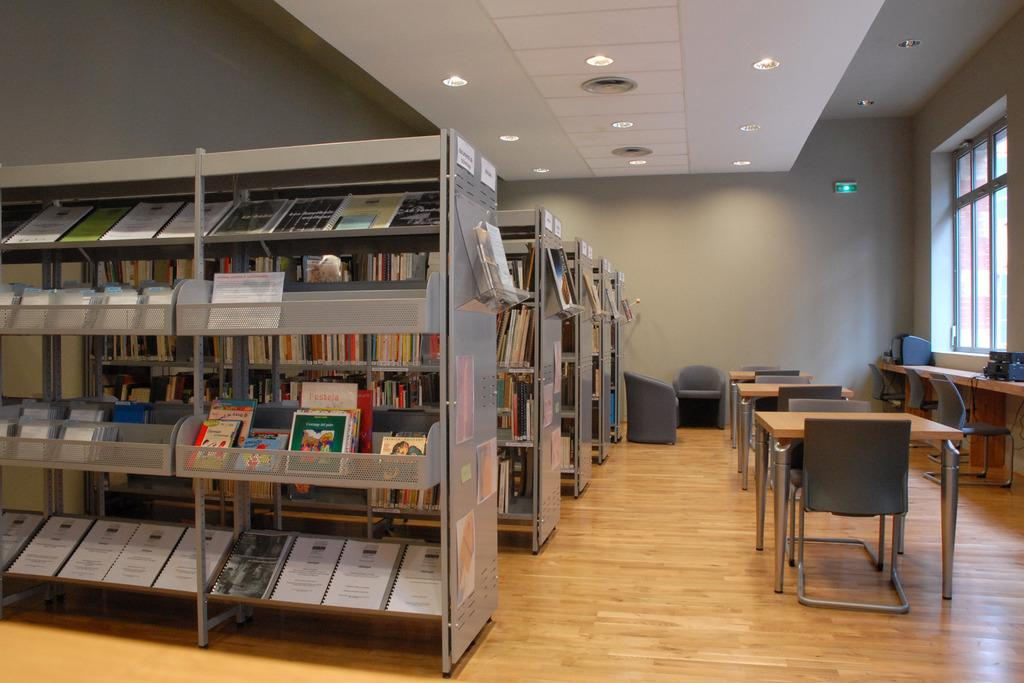What is stored on the racks in the image? The racks are filled with books. What type of lighting is present in the image? There are lights on top of the racks. What type of furniture is visible in the image? Chairs and tables are present in the image. What can be seen through the window in the image? The presence of a window suggests that there might be a view or outdoor scene visible, but the specifics are not mentioned in the facts. What type of impulse can be seen affecting the books on the racks in the image? There is no mention of any impulse affecting the books in the image. Is there a party happening in the image? There is no indication of a party or any celebratory event in the image. 